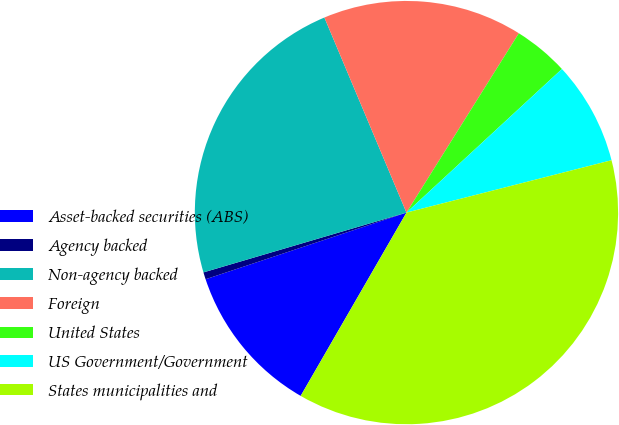Convert chart to OTSL. <chart><loc_0><loc_0><loc_500><loc_500><pie_chart><fcel>Asset-backed securities (ABS)<fcel>Agency backed<fcel>Non-agency backed<fcel>Foreign<fcel>United States<fcel>US Government/Government<fcel>States municipalities and<nl><fcel>11.57%<fcel>0.54%<fcel>23.22%<fcel>15.25%<fcel>4.22%<fcel>7.89%<fcel>37.31%<nl></chart> 